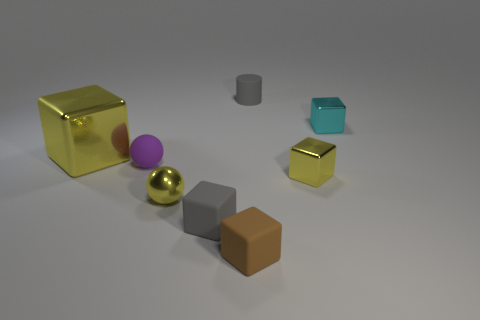There is a big thing; is its color the same as the small metallic thing left of the small cylinder?
Your answer should be very brief. Yes. There is a object that is behind the purple sphere and on the left side of the matte cylinder; what color is it?
Keep it short and to the point. Yellow. Are there fewer large cyan blocks than big metallic cubes?
Provide a short and direct response. Yes. Is the material of the big cube the same as the tiny gray thing that is behind the yellow metallic sphere?
Your answer should be very brief. No. What is the shape of the metallic object that is on the left side of the small purple rubber thing?
Your response must be concise. Cube. Is there any other thing of the same color as the large metallic cube?
Offer a very short reply. Yes. Is the number of small matte blocks that are on the right side of the large shiny block less than the number of yellow metal balls?
Make the answer very short. No. How many purple cylinders are the same size as the purple rubber sphere?
Your answer should be compact. 0. What shape is the matte thing that is the same color as the tiny cylinder?
Offer a very short reply. Cube. What shape is the brown thing left of the tiny yellow metallic object to the right of the tiny gray rubber thing behind the yellow sphere?
Offer a very short reply. Cube. 